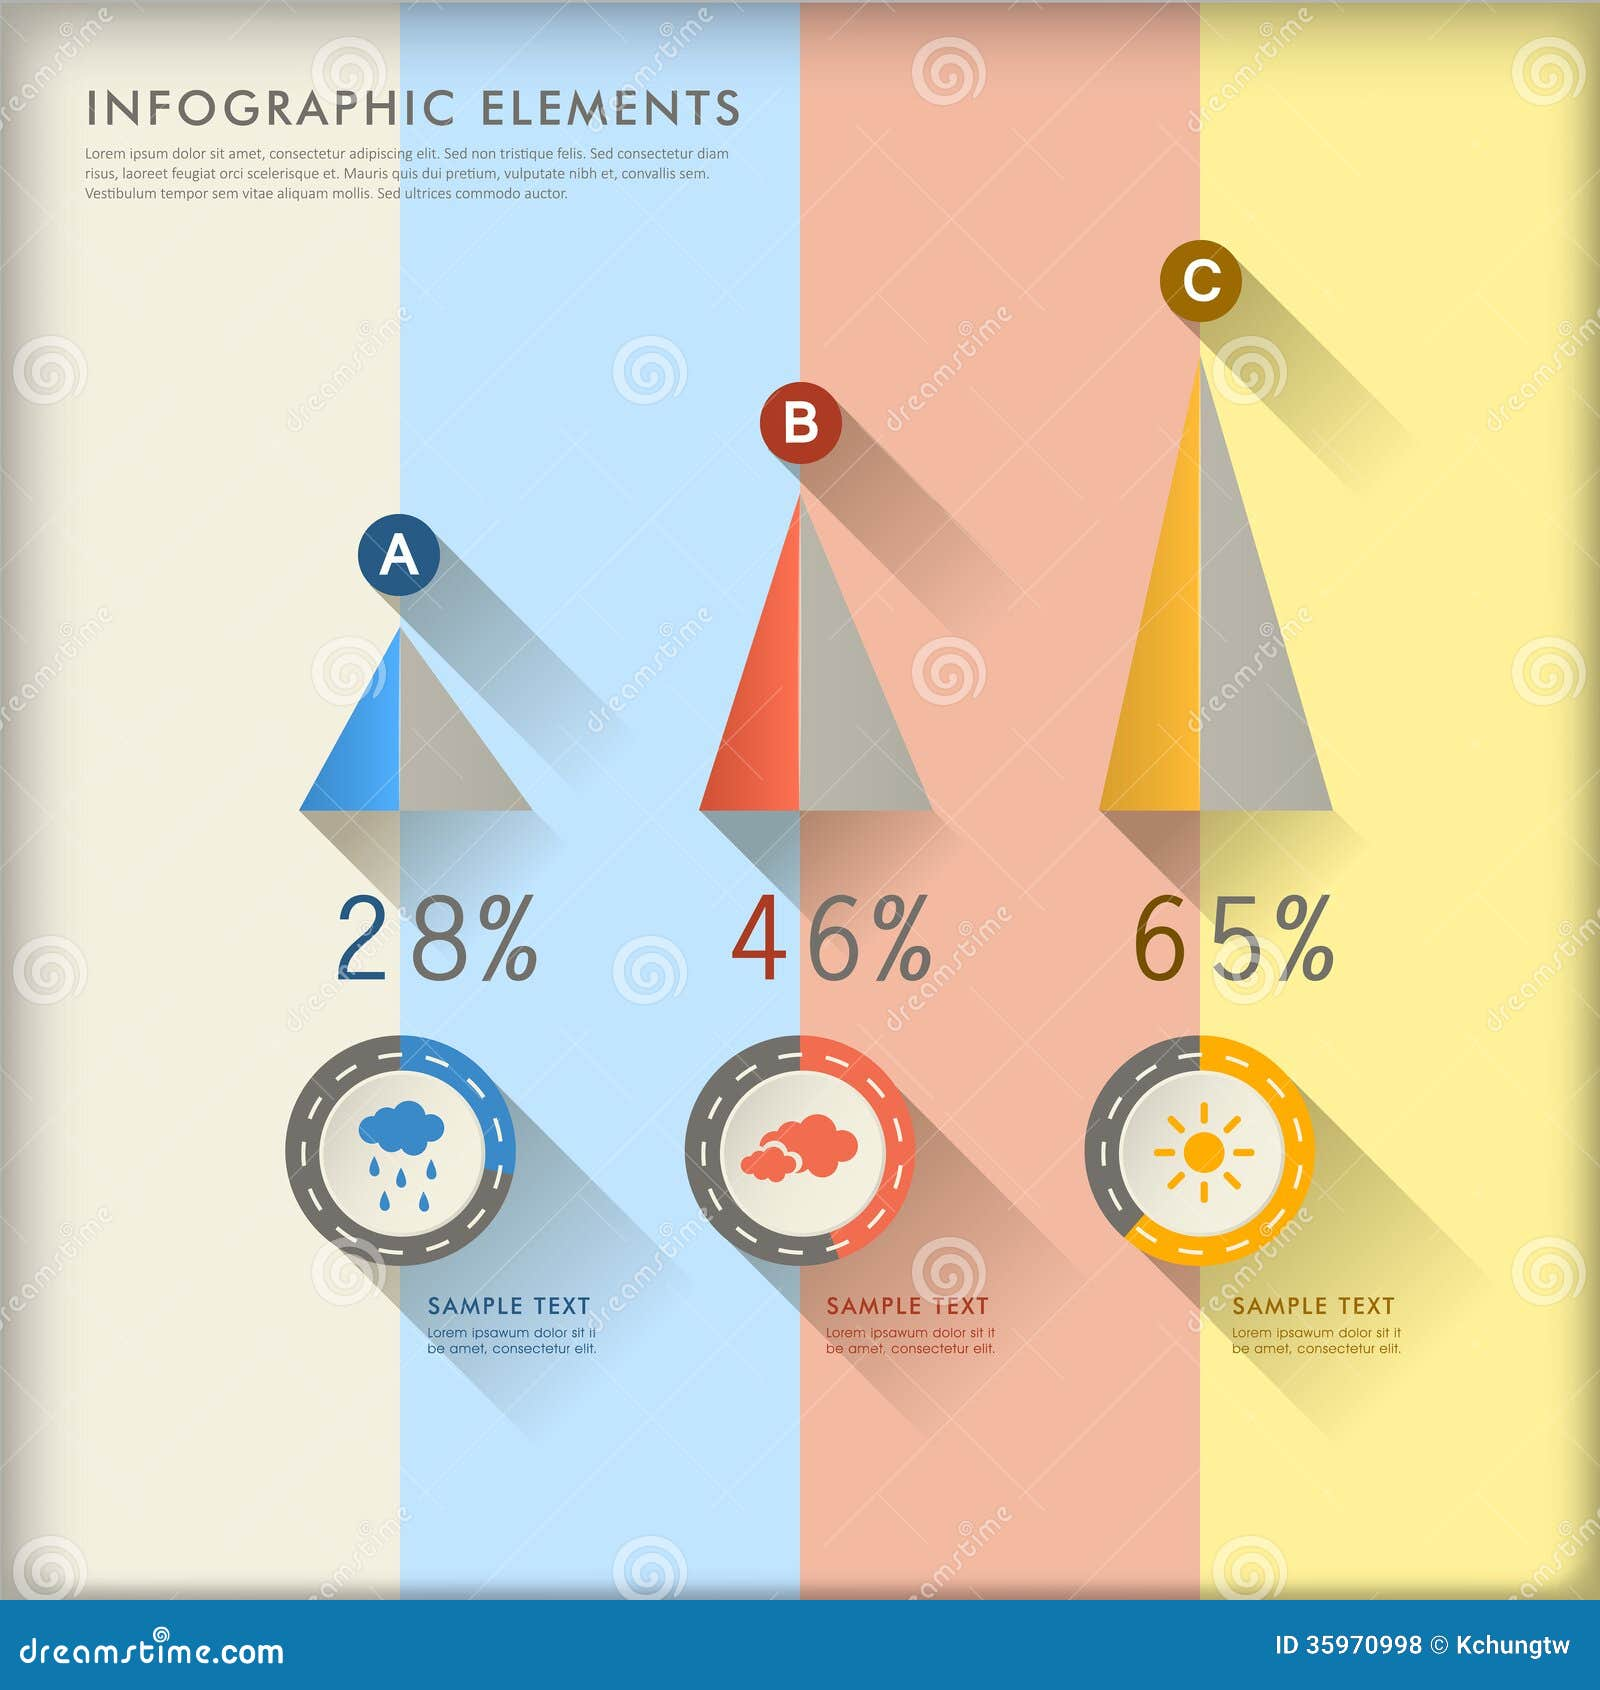How would you redesign this infographic to represent a fictional world where fantasy creatures' populations are depicted instead? Redesigning this infographic to depict the populations of fantasy creatures, I would start by replacing the current icons with illustrations of different fantasy beings, such as dragons, unicorns, and elves. The color themes would correspond to mystical and magical elements, perhaps using shades of green, gold, and blue to symbolize the different habitats or realms these creatures belong to. For example, dragons could be represented in fiery red with 28%, unicorns in ethereal blue with 46%, and elves in forest green with 65%. The pyramids could be redesigned with mythical artifacts like towers or enchanted trees to make the infographic more immersive and visually appealing. 